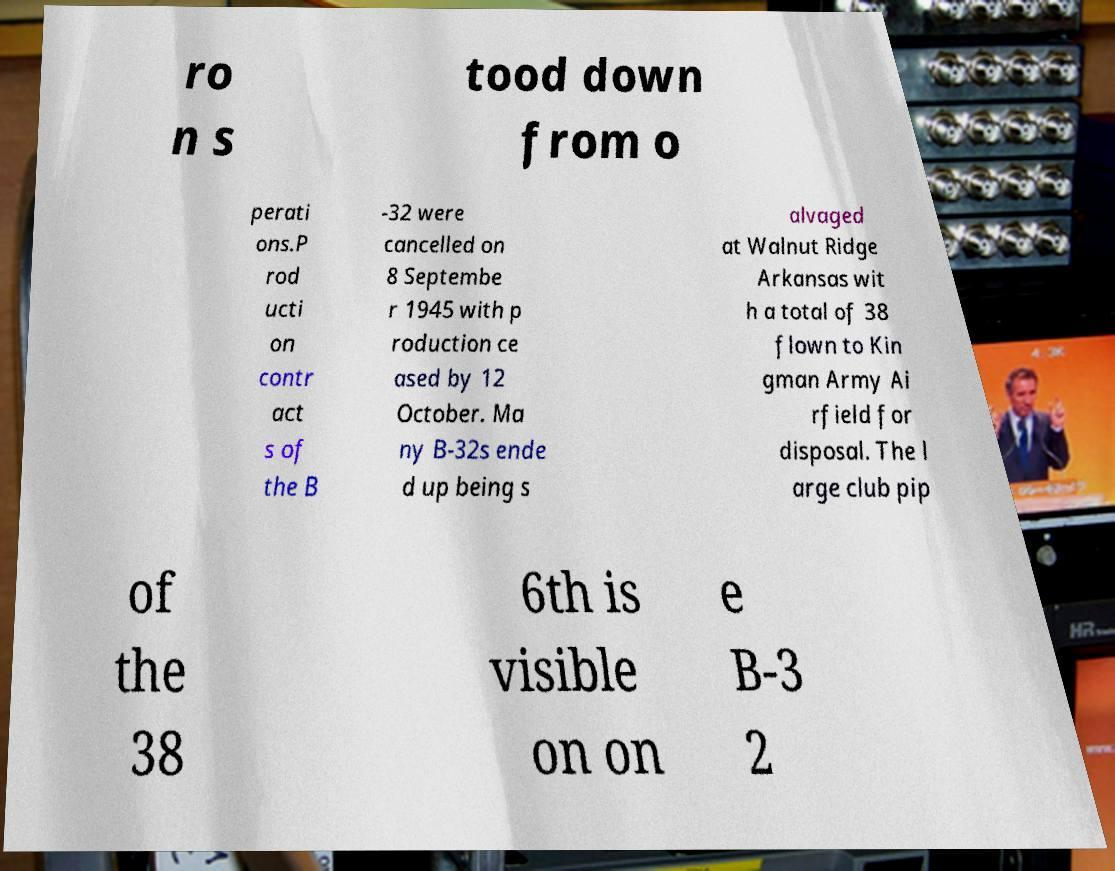I need the written content from this picture converted into text. Can you do that? ro n s tood down from o perati ons.P rod ucti on contr act s of the B -32 were cancelled on 8 Septembe r 1945 with p roduction ce ased by 12 October. Ma ny B-32s ende d up being s alvaged at Walnut Ridge Arkansas wit h a total of 38 flown to Kin gman Army Ai rfield for disposal. The l arge club pip of the 38 6th is visible on on e B-3 2 